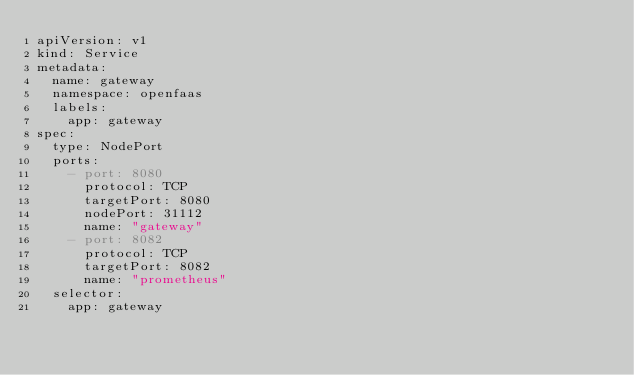Convert code to text. <code><loc_0><loc_0><loc_500><loc_500><_YAML_>apiVersion: v1
kind: Service
metadata:
  name: gateway
  namespace: openfaas
  labels:
    app: gateway
spec:
  type: NodePort
  ports:
    - port: 8080
      protocol: TCP
      targetPort: 8080
      nodePort: 31112
      name: "gateway"
    - port: 8082
      protocol: TCP
      targetPort: 8082
      name: "prometheus"
  selector:
    app: gateway
</code> 